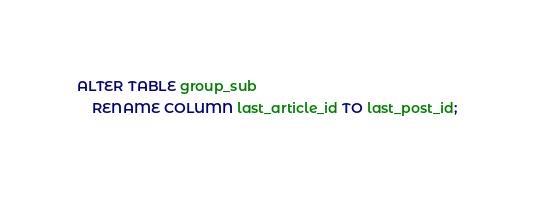Convert code to text. <code><loc_0><loc_0><loc_500><loc_500><_SQL_>ALTER TABLE group_sub
    RENAME COLUMN last_article_id TO last_post_id;
</code> 